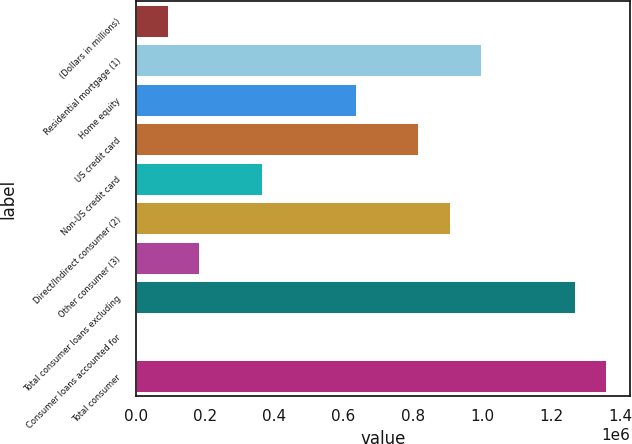Convert chart. <chart><loc_0><loc_0><loc_500><loc_500><bar_chart><fcel>(Dollars in millions)<fcel>Residential mortgage (1)<fcel>Home equity<fcel>US credit card<fcel>Non-US credit card<fcel>Direct/Indirect consumer (2)<fcel>Other consumer (3)<fcel>Total consumer loans excluding<fcel>Consumer loans accounted for<fcel>Total consumer<nl><fcel>91614.2<fcel>997246<fcel>634993<fcel>816120<fcel>363304<fcel>906683<fcel>182177<fcel>1.26894e+06<fcel>1051<fcel>1.3595e+06<nl></chart> 